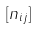<formula> <loc_0><loc_0><loc_500><loc_500>[ n _ { i j } ]</formula> 